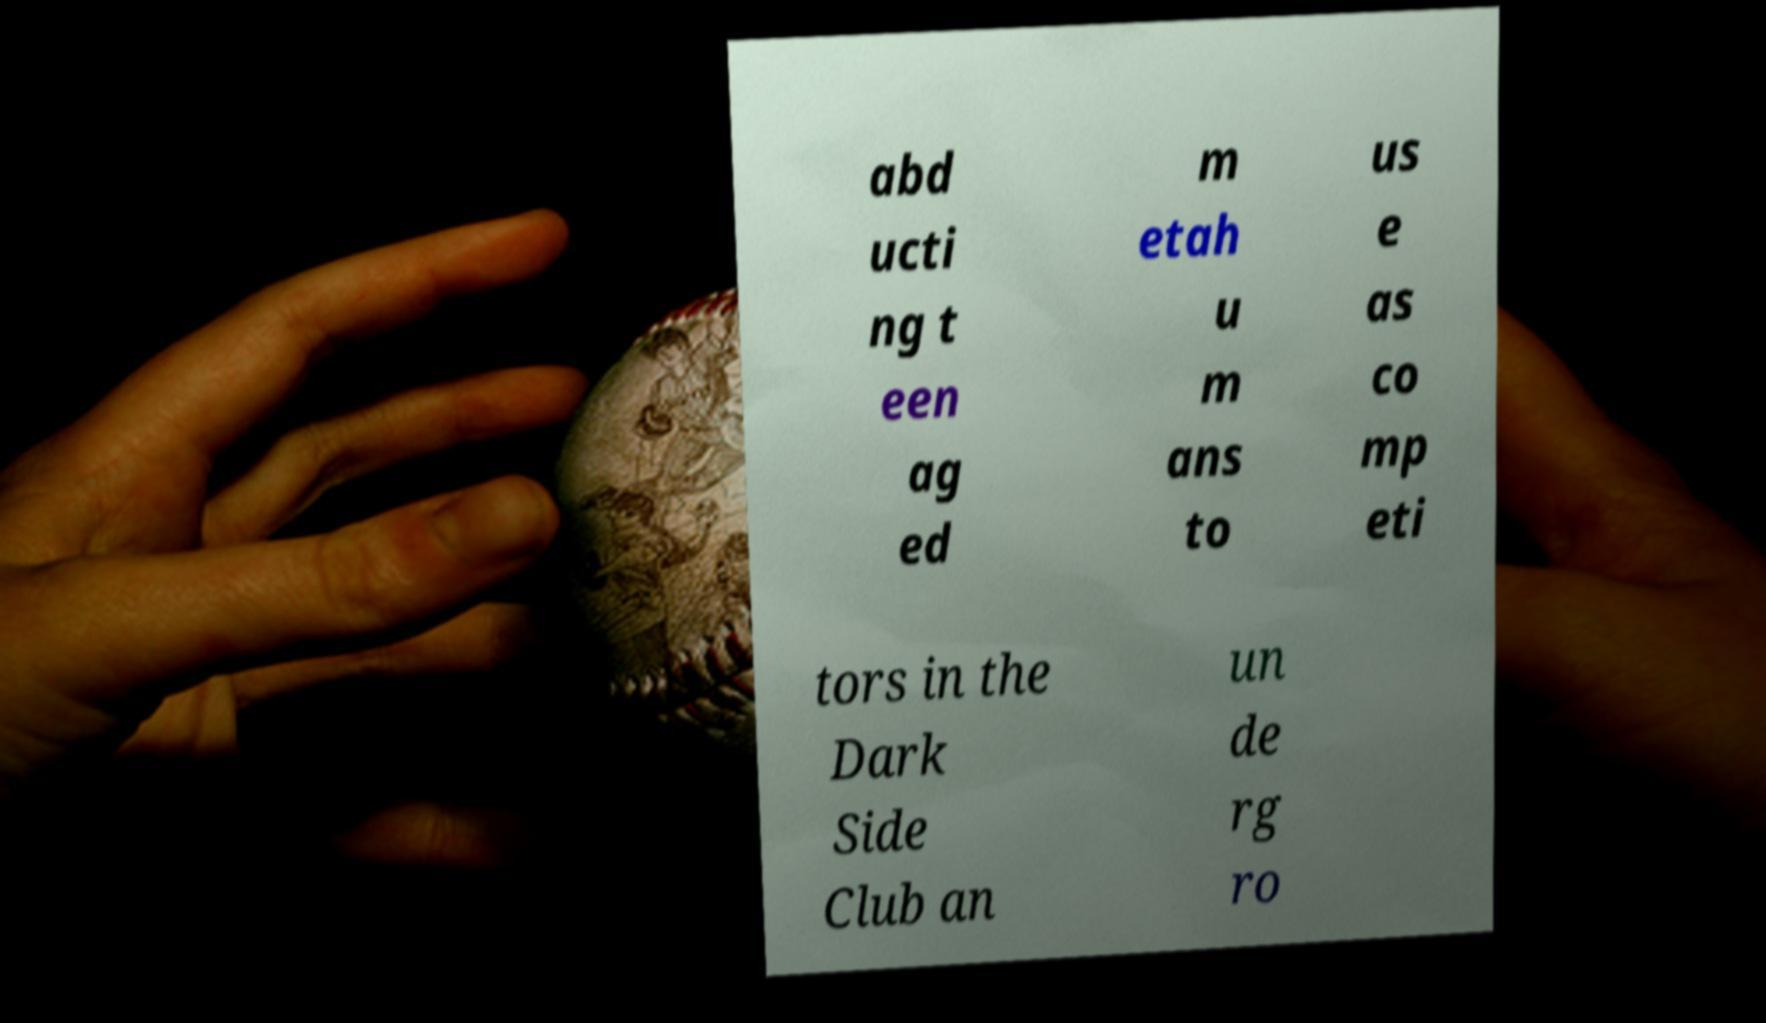Can you accurately transcribe the text from the provided image for me? abd ucti ng t een ag ed m etah u m ans to us e as co mp eti tors in the Dark Side Club an un de rg ro 